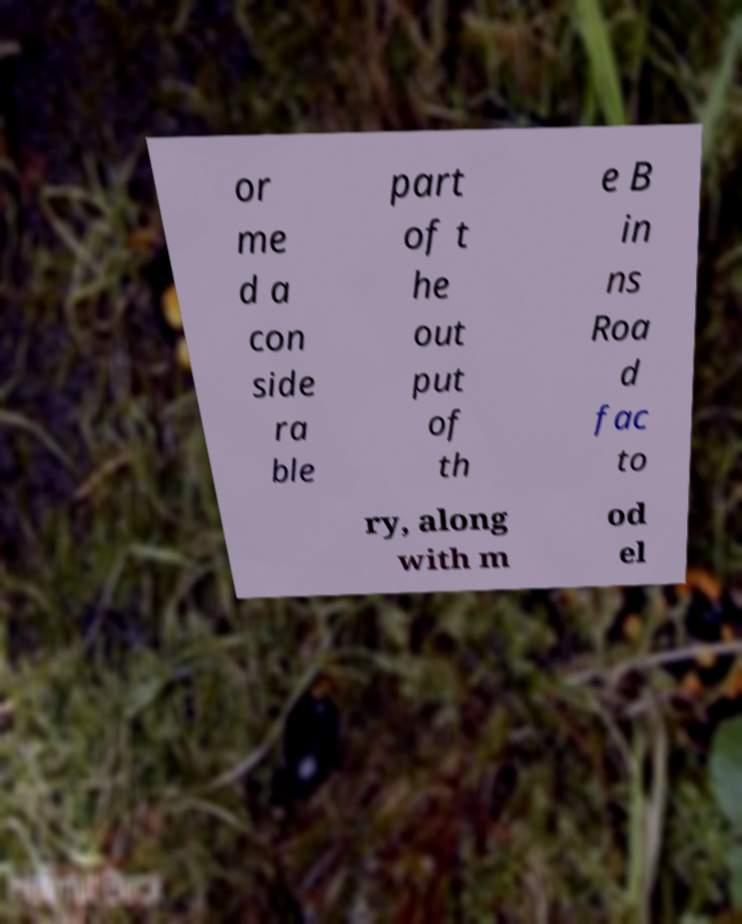For documentation purposes, I need the text within this image transcribed. Could you provide that? or me d a con side ra ble part of t he out put of th e B in ns Roa d fac to ry, along with m od el 